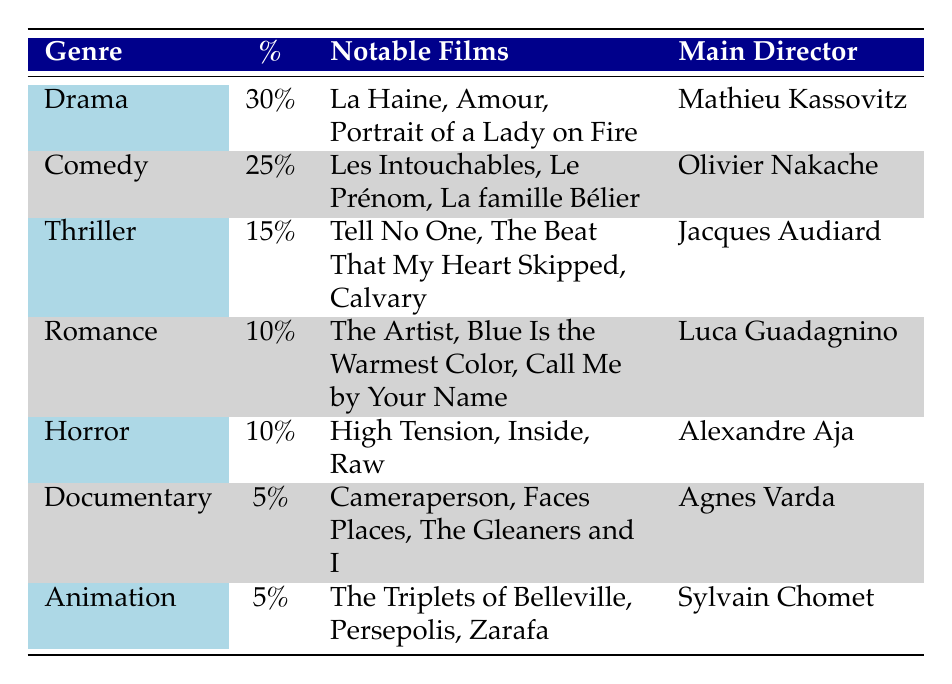What is the genre with the highest percentage in French cinema? The table shows that Drama has the highest percentage at 30%.
Answer: Drama Which director is associated with the Comedy genre? According to the table, the main director of the Comedy genre is Olivier Nakache.
Answer: Olivier Nakache How many genres have a percentage of 10%? The table lists two genres, Romance and Horror, that each have a percentage of 10%.
Answer: 2 What is the total percentage of genres that are represented by less than 10%? Looking at the table, the only genres that are represented by less than 10% are Documentary and Animation, each with 5%. Thus, the total percentage is 5% + 5% = 10%.
Answer: 10% Is the main director of the Horror genre different from that of the Drama genre? The table indicates that the main director of the Horror genre is Alexandre Aja and the main director of the Drama genre is Mathieu Kassovitz, which confirms they are different.
Answer: Yes What percentage of the films are classified as either Documentary or Animation? The percentage for Documentary is 5% and for Animation is also 5%. Summing these gives 5% + 5% = 10%.
Answer: 10% Which genre has notable films that were directed by Jacques Audiard? According to the table, the Thriller genre has notable films directed by Jacques Audiard.
Answer: Thriller What are the three genres that have a notable film count of three on the list? Drama, Comedy, and Thriller each list three notable films in the table.
Answer: Drama, Comedy, Thriller If you combine the percentages of Drama and Comedy, how much do they account for together? The percentage for Drama is 30% and for Comedy is 25%. So, the combined percentage is 30% + 25% = 55%.
Answer: 55% Is Agnès Varda the main director of a genre that is more common than Animation in terms of percentage? The table shows that Documentary with 5% is not more common than Animation also at 5%. Therefore, the answer is no.
Answer: No 